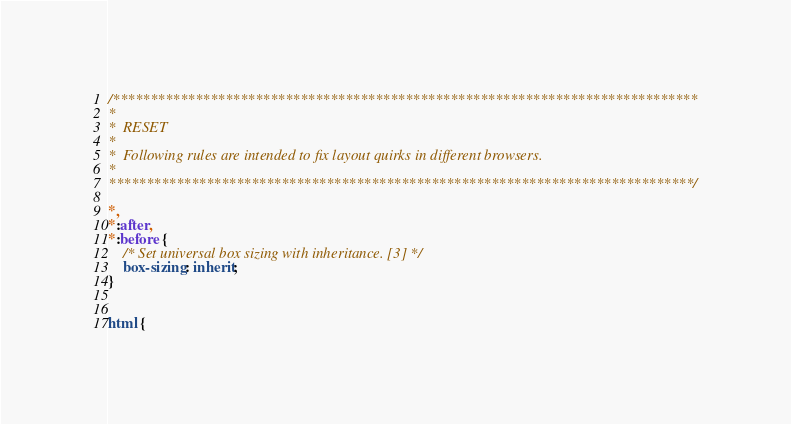<code> <loc_0><loc_0><loc_500><loc_500><_CSS_>/******************************************************************************
*
*  RESET
*
*  Following rules are intended to fix layout quirks in different browsers.
* 
******************************************************************************/

*,
*:after,
*:before {
	/* Set universal box sizing with inheritance. [3] */
	box-sizing: inherit;
}


html {</code> 